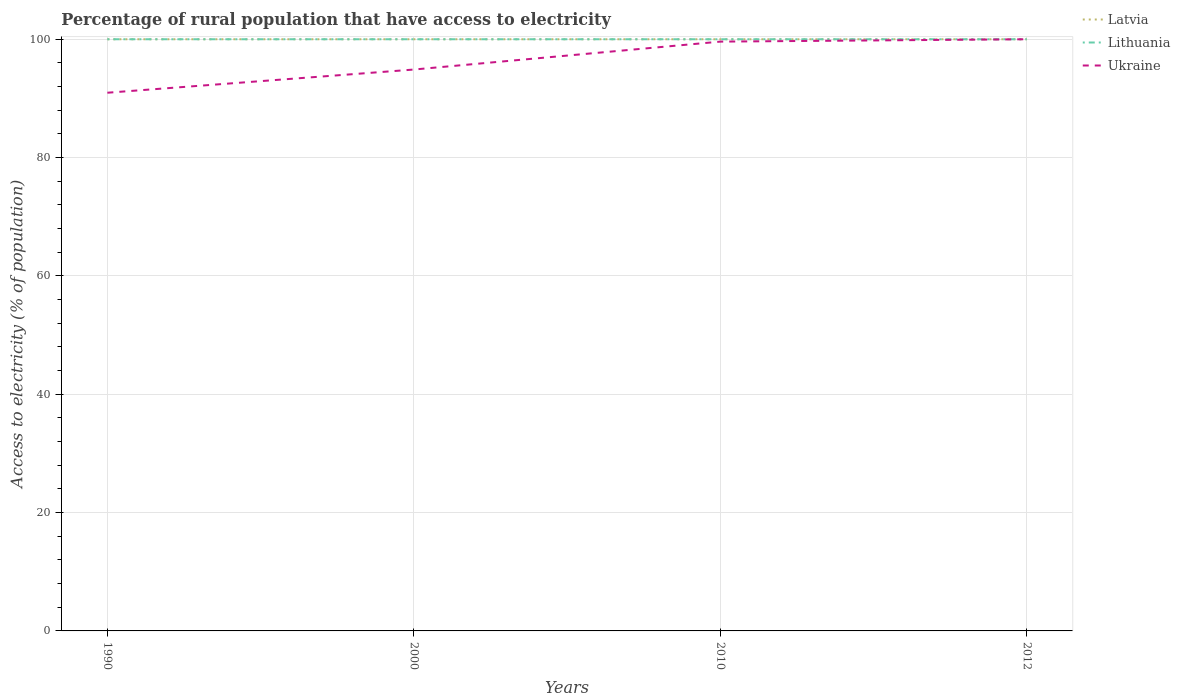Does the line corresponding to Ukraine intersect with the line corresponding to Latvia?
Ensure brevity in your answer.  Yes. Across all years, what is the maximum percentage of rural population that have access to electricity in Latvia?
Ensure brevity in your answer.  100. In which year was the percentage of rural population that have access to electricity in Ukraine maximum?
Provide a succinct answer. 1990. What is the total percentage of rural population that have access to electricity in Lithuania in the graph?
Make the answer very short. 0. How many lines are there?
Ensure brevity in your answer.  3. Are the values on the major ticks of Y-axis written in scientific E-notation?
Give a very brief answer. No. Does the graph contain any zero values?
Offer a very short reply. No. Where does the legend appear in the graph?
Offer a terse response. Top right. How many legend labels are there?
Keep it short and to the point. 3. How are the legend labels stacked?
Keep it short and to the point. Vertical. What is the title of the graph?
Provide a short and direct response. Percentage of rural population that have access to electricity. What is the label or title of the Y-axis?
Provide a succinct answer. Access to electricity (% of population). What is the Access to electricity (% of population) in Lithuania in 1990?
Ensure brevity in your answer.  100. What is the Access to electricity (% of population) of Ukraine in 1990?
Provide a short and direct response. 90.96. What is the Access to electricity (% of population) of Lithuania in 2000?
Provide a short and direct response. 100. What is the Access to electricity (% of population) of Ukraine in 2000?
Your answer should be very brief. 94.88. What is the Access to electricity (% of population) of Latvia in 2010?
Your answer should be compact. 100. What is the Access to electricity (% of population) of Ukraine in 2010?
Keep it short and to the point. 99.6. What is the Access to electricity (% of population) in Latvia in 2012?
Make the answer very short. 100. What is the Access to electricity (% of population) in Ukraine in 2012?
Offer a very short reply. 100. Across all years, what is the maximum Access to electricity (% of population) in Lithuania?
Provide a succinct answer. 100. Across all years, what is the maximum Access to electricity (% of population) of Ukraine?
Ensure brevity in your answer.  100. Across all years, what is the minimum Access to electricity (% of population) in Lithuania?
Keep it short and to the point. 100. Across all years, what is the minimum Access to electricity (% of population) in Ukraine?
Your answer should be very brief. 90.96. What is the total Access to electricity (% of population) of Latvia in the graph?
Ensure brevity in your answer.  400. What is the total Access to electricity (% of population) of Lithuania in the graph?
Provide a short and direct response. 400. What is the total Access to electricity (% of population) in Ukraine in the graph?
Your answer should be very brief. 385.44. What is the difference between the Access to electricity (% of population) of Latvia in 1990 and that in 2000?
Offer a very short reply. 0. What is the difference between the Access to electricity (% of population) in Ukraine in 1990 and that in 2000?
Ensure brevity in your answer.  -3.92. What is the difference between the Access to electricity (% of population) of Lithuania in 1990 and that in 2010?
Offer a terse response. 0. What is the difference between the Access to electricity (% of population) in Ukraine in 1990 and that in 2010?
Give a very brief answer. -8.64. What is the difference between the Access to electricity (% of population) of Latvia in 1990 and that in 2012?
Keep it short and to the point. 0. What is the difference between the Access to electricity (% of population) of Ukraine in 1990 and that in 2012?
Make the answer very short. -9.04. What is the difference between the Access to electricity (% of population) of Latvia in 2000 and that in 2010?
Make the answer very short. 0. What is the difference between the Access to electricity (% of population) of Ukraine in 2000 and that in 2010?
Make the answer very short. -4.72. What is the difference between the Access to electricity (% of population) of Latvia in 2000 and that in 2012?
Offer a terse response. 0. What is the difference between the Access to electricity (% of population) in Lithuania in 2000 and that in 2012?
Your answer should be compact. 0. What is the difference between the Access to electricity (% of population) of Ukraine in 2000 and that in 2012?
Ensure brevity in your answer.  -5.12. What is the difference between the Access to electricity (% of population) in Latvia in 2010 and that in 2012?
Offer a terse response. 0. What is the difference between the Access to electricity (% of population) of Lithuania in 2010 and that in 2012?
Your response must be concise. 0. What is the difference between the Access to electricity (% of population) in Latvia in 1990 and the Access to electricity (% of population) in Ukraine in 2000?
Offer a very short reply. 5.12. What is the difference between the Access to electricity (% of population) of Lithuania in 1990 and the Access to electricity (% of population) of Ukraine in 2000?
Offer a terse response. 5.12. What is the difference between the Access to electricity (% of population) in Latvia in 1990 and the Access to electricity (% of population) in Lithuania in 2010?
Your answer should be very brief. 0. What is the difference between the Access to electricity (% of population) of Latvia in 1990 and the Access to electricity (% of population) of Ukraine in 2010?
Offer a very short reply. 0.4. What is the difference between the Access to electricity (% of population) of Latvia in 1990 and the Access to electricity (% of population) of Lithuania in 2012?
Your answer should be compact. 0. What is the difference between the Access to electricity (% of population) of Latvia in 1990 and the Access to electricity (% of population) of Ukraine in 2012?
Provide a short and direct response. 0. What is the difference between the Access to electricity (% of population) of Latvia in 2000 and the Access to electricity (% of population) of Lithuania in 2012?
Your answer should be very brief. 0. What is the difference between the Access to electricity (% of population) in Latvia in 2000 and the Access to electricity (% of population) in Ukraine in 2012?
Your answer should be very brief. 0. What is the difference between the Access to electricity (% of population) in Lithuania in 2000 and the Access to electricity (% of population) in Ukraine in 2012?
Your answer should be compact. 0. What is the difference between the Access to electricity (% of population) in Lithuania in 2010 and the Access to electricity (% of population) in Ukraine in 2012?
Offer a very short reply. 0. What is the average Access to electricity (% of population) in Lithuania per year?
Your response must be concise. 100. What is the average Access to electricity (% of population) of Ukraine per year?
Offer a very short reply. 96.36. In the year 1990, what is the difference between the Access to electricity (% of population) in Latvia and Access to electricity (% of population) in Ukraine?
Offer a terse response. 9.04. In the year 1990, what is the difference between the Access to electricity (% of population) in Lithuania and Access to electricity (% of population) in Ukraine?
Your response must be concise. 9.04. In the year 2000, what is the difference between the Access to electricity (% of population) in Latvia and Access to electricity (% of population) in Lithuania?
Offer a very short reply. 0. In the year 2000, what is the difference between the Access to electricity (% of population) of Latvia and Access to electricity (% of population) of Ukraine?
Give a very brief answer. 5.12. In the year 2000, what is the difference between the Access to electricity (% of population) of Lithuania and Access to electricity (% of population) of Ukraine?
Ensure brevity in your answer.  5.12. In the year 2010, what is the difference between the Access to electricity (% of population) of Latvia and Access to electricity (% of population) of Lithuania?
Offer a very short reply. 0. In the year 2012, what is the difference between the Access to electricity (% of population) in Lithuania and Access to electricity (% of population) in Ukraine?
Offer a very short reply. 0. What is the ratio of the Access to electricity (% of population) of Latvia in 1990 to that in 2000?
Provide a short and direct response. 1. What is the ratio of the Access to electricity (% of population) of Lithuania in 1990 to that in 2000?
Your answer should be very brief. 1. What is the ratio of the Access to electricity (% of population) of Ukraine in 1990 to that in 2000?
Ensure brevity in your answer.  0.96. What is the ratio of the Access to electricity (% of population) of Ukraine in 1990 to that in 2010?
Your answer should be very brief. 0.91. What is the ratio of the Access to electricity (% of population) of Lithuania in 1990 to that in 2012?
Ensure brevity in your answer.  1. What is the ratio of the Access to electricity (% of population) in Ukraine in 1990 to that in 2012?
Your answer should be compact. 0.91. What is the ratio of the Access to electricity (% of population) in Ukraine in 2000 to that in 2010?
Give a very brief answer. 0.95. What is the ratio of the Access to electricity (% of population) in Latvia in 2000 to that in 2012?
Provide a succinct answer. 1. What is the ratio of the Access to electricity (% of population) of Ukraine in 2000 to that in 2012?
Make the answer very short. 0.95. What is the ratio of the Access to electricity (% of population) in Lithuania in 2010 to that in 2012?
Provide a short and direct response. 1. What is the ratio of the Access to electricity (% of population) of Ukraine in 2010 to that in 2012?
Provide a succinct answer. 1. What is the difference between the highest and the second highest Access to electricity (% of population) in Latvia?
Keep it short and to the point. 0. What is the difference between the highest and the second highest Access to electricity (% of population) in Lithuania?
Offer a terse response. 0. What is the difference between the highest and the second highest Access to electricity (% of population) in Ukraine?
Your response must be concise. 0.4. What is the difference between the highest and the lowest Access to electricity (% of population) of Latvia?
Offer a terse response. 0. What is the difference between the highest and the lowest Access to electricity (% of population) in Ukraine?
Your response must be concise. 9.04. 